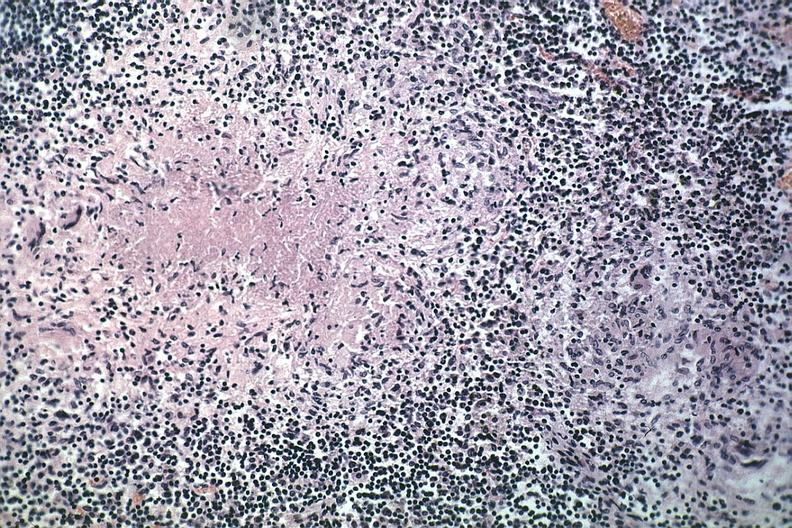s stein leventhal present?
Answer the question using a single word or phrase. No 